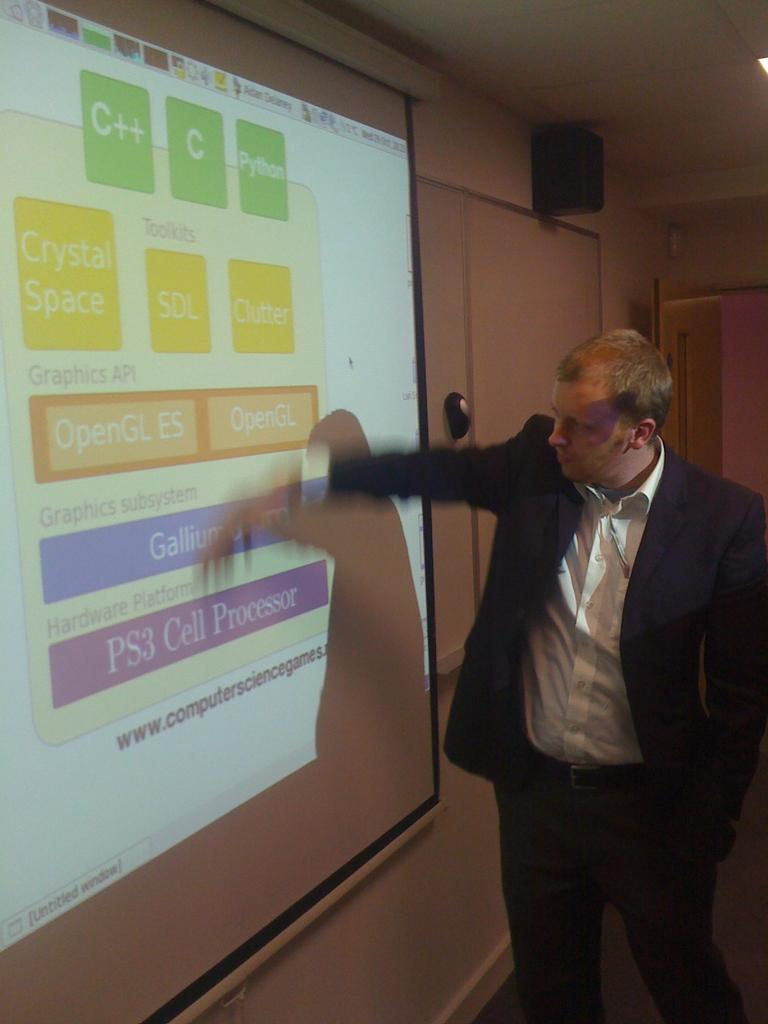Who is the main subject in the image? There is an old man in the image. What is the old man wearing? The old man is wearing a black suit and a white shirt. What is the old man doing in the image? The old man is standing and looking at a screen on the wall. What can be seen on the ceiling in the image? There is a speaker on the ceiling in the image. Where is the door located in the image? There is a door below the speaker in the image. Can you tell me what advice the kitten is giving to the old man in the image? There is no kitten present in the image, so it is not possible to determine any advice given. 